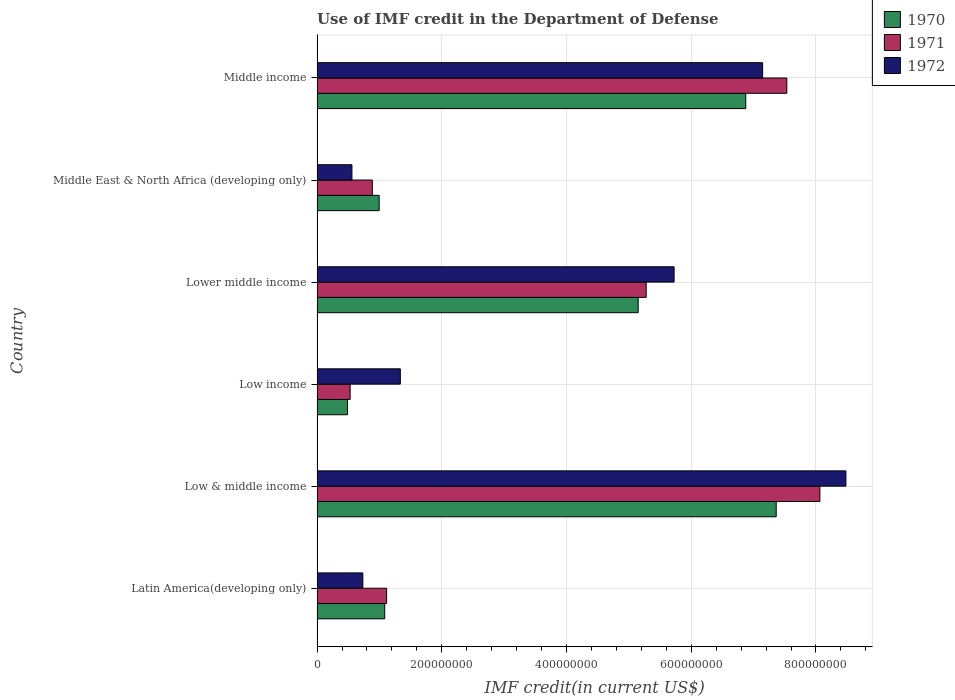How many different coloured bars are there?
Offer a terse response. 3. Are the number of bars on each tick of the Y-axis equal?
Your answer should be very brief. Yes. How many bars are there on the 4th tick from the top?
Provide a short and direct response. 3. What is the label of the 6th group of bars from the top?
Keep it short and to the point. Latin America(developing only). In how many cases, is the number of bars for a given country not equal to the number of legend labels?
Your answer should be compact. 0. What is the IMF credit in the Department of Defense in 1971 in Middle income?
Your response must be concise. 7.53e+08. Across all countries, what is the maximum IMF credit in the Department of Defense in 1971?
Provide a succinct answer. 8.06e+08. Across all countries, what is the minimum IMF credit in the Department of Defense in 1972?
Offer a terse response. 5.59e+07. In which country was the IMF credit in the Department of Defense in 1972 maximum?
Give a very brief answer. Low & middle income. In which country was the IMF credit in the Department of Defense in 1972 minimum?
Make the answer very short. Middle East & North Africa (developing only). What is the total IMF credit in the Department of Defense in 1972 in the graph?
Ensure brevity in your answer.  2.40e+09. What is the difference between the IMF credit in the Department of Defense in 1970 in Middle East & North Africa (developing only) and that in Middle income?
Offer a terse response. -5.88e+08. What is the difference between the IMF credit in the Department of Defense in 1971 in Middle income and the IMF credit in the Department of Defense in 1972 in Low & middle income?
Keep it short and to the point. -9.48e+07. What is the average IMF credit in the Department of Defense in 1971 per country?
Offer a terse response. 3.90e+08. What is the difference between the IMF credit in the Department of Defense in 1970 and IMF credit in the Department of Defense in 1972 in Low & middle income?
Provide a short and direct response. -1.12e+08. In how many countries, is the IMF credit in the Department of Defense in 1971 greater than 800000000 US$?
Keep it short and to the point. 1. What is the ratio of the IMF credit in the Department of Defense in 1971 in Lower middle income to that in Middle income?
Keep it short and to the point. 0.7. What is the difference between the highest and the second highest IMF credit in the Department of Defense in 1971?
Make the answer very short. 5.30e+07. What is the difference between the highest and the lowest IMF credit in the Department of Defense in 1970?
Give a very brief answer. 6.87e+08. In how many countries, is the IMF credit in the Department of Defense in 1970 greater than the average IMF credit in the Department of Defense in 1970 taken over all countries?
Your response must be concise. 3. What does the 3rd bar from the bottom in Middle East & North Africa (developing only) represents?
Keep it short and to the point. 1972. Are all the bars in the graph horizontal?
Provide a short and direct response. Yes. How many countries are there in the graph?
Offer a terse response. 6. What is the difference between two consecutive major ticks on the X-axis?
Your answer should be compact. 2.00e+08. Are the values on the major ticks of X-axis written in scientific E-notation?
Your response must be concise. No. Does the graph contain any zero values?
Offer a terse response. No. How many legend labels are there?
Your answer should be compact. 3. How are the legend labels stacked?
Keep it short and to the point. Vertical. What is the title of the graph?
Your answer should be very brief. Use of IMF credit in the Department of Defense. What is the label or title of the X-axis?
Your answer should be very brief. IMF credit(in current US$). What is the label or title of the Y-axis?
Offer a very short reply. Country. What is the IMF credit(in current US$) of 1970 in Latin America(developing only)?
Provide a short and direct response. 1.09e+08. What is the IMF credit(in current US$) of 1971 in Latin America(developing only)?
Your answer should be compact. 1.12e+08. What is the IMF credit(in current US$) of 1972 in Latin America(developing only)?
Ensure brevity in your answer.  7.34e+07. What is the IMF credit(in current US$) in 1970 in Low & middle income?
Your answer should be very brief. 7.36e+08. What is the IMF credit(in current US$) of 1971 in Low & middle income?
Keep it short and to the point. 8.06e+08. What is the IMF credit(in current US$) in 1972 in Low & middle income?
Your answer should be compact. 8.48e+08. What is the IMF credit(in current US$) in 1970 in Low income?
Offer a terse response. 4.88e+07. What is the IMF credit(in current US$) of 1971 in Low income?
Ensure brevity in your answer.  5.30e+07. What is the IMF credit(in current US$) of 1972 in Low income?
Keep it short and to the point. 1.34e+08. What is the IMF credit(in current US$) of 1970 in Lower middle income?
Offer a very short reply. 5.15e+08. What is the IMF credit(in current US$) of 1971 in Lower middle income?
Keep it short and to the point. 5.28e+08. What is the IMF credit(in current US$) in 1972 in Lower middle income?
Offer a very short reply. 5.73e+08. What is the IMF credit(in current US$) in 1970 in Middle East & North Africa (developing only)?
Ensure brevity in your answer.  9.96e+07. What is the IMF credit(in current US$) of 1971 in Middle East & North Africa (developing only)?
Keep it short and to the point. 8.86e+07. What is the IMF credit(in current US$) of 1972 in Middle East & North Africa (developing only)?
Offer a terse response. 5.59e+07. What is the IMF credit(in current US$) of 1970 in Middle income?
Provide a short and direct response. 6.87e+08. What is the IMF credit(in current US$) of 1971 in Middle income?
Keep it short and to the point. 7.53e+08. What is the IMF credit(in current US$) in 1972 in Middle income?
Keep it short and to the point. 7.14e+08. Across all countries, what is the maximum IMF credit(in current US$) in 1970?
Ensure brevity in your answer.  7.36e+08. Across all countries, what is the maximum IMF credit(in current US$) of 1971?
Ensure brevity in your answer.  8.06e+08. Across all countries, what is the maximum IMF credit(in current US$) in 1972?
Your response must be concise. 8.48e+08. Across all countries, what is the minimum IMF credit(in current US$) in 1970?
Provide a succinct answer. 4.88e+07. Across all countries, what is the minimum IMF credit(in current US$) of 1971?
Provide a short and direct response. 5.30e+07. Across all countries, what is the minimum IMF credit(in current US$) in 1972?
Ensure brevity in your answer.  5.59e+07. What is the total IMF credit(in current US$) in 1970 in the graph?
Keep it short and to the point. 2.20e+09. What is the total IMF credit(in current US$) in 1971 in the graph?
Offer a terse response. 2.34e+09. What is the total IMF credit(in current US$) of 1972 in the graph?
Your answer should be very brief. 2.40e+09. What is the difference between the IMF credit(in current US$) of 1970 in Latin America(developing only) and that in Low & middle income?
Offer a very short reply. -6.28e+08. What is the difference between the IMF credit(in current US$) in 1971 in Latin America(developing only) and that in Low & middle income?
Your answer should be very brief. -6.95e+08. What is the difference between the IMF credit(in current US$) of 1972 in Latin America(developing only) and that in Low & middle income?
Make the answer very short. -7.75e+08. What is the difference between the IMF credit(in current US$) of 1970 in Latin America(developing only) and that in Low income?
Offer a terse response. 5.97e+07. What is the difference between the IMF credit(in current US$) in 1971 in Latin America(developing only) and that in Low income?
Give a very brief answer. 5.85e+07. What is the difference between the IMF credit(in current US$) in 1972 in Latin America(developing only) and that in Low income?
Your answer should be very brief. -6.01e+07. What is the difference between the IMF credit(in current US$) in 1970 in Latin America(developing only) and that in Lower middle income?
Your response must be concise. -4.06e+08. What is the difference between the IMF credit(in current US$) of 1971 in Latin America(developing only) and that in Lower middle income?
Make the answer very short. -4.16e+08. What is the difference between the IMF credit(in current US$) in 1972 in Latin America(developing only) and that in Lower middle income?
Your response must be concise. -4.99e+08. What is the difference between the IMF credit(in current US$) of 1970 in Latin America(developing only) and that in Middle East & North Africa (developing only)?
Ensure brevity in your answer.  8.90e+06. What is the difference between the IMF credit(in current US$) in 1971 in Latin America(developing only) and that in Middle East & North Africa (developing only)?
Your response must be concise. 2.29e+07. What is the difference between the IMF credit(in current US$) of 1972 in Latin America(developing only) and that in Middle East & North Africa (developing only)?
Keep it short and to the point. 1.75e+07. What is the difference between the IMF credit(in current US$) of 1970 in Latin America(developing only) and that in Middle income?
Ensure brevity in your answer.  -5.79e+08. What is the difference between the IMF credit(in current US$) of 1971 in Latin America(developing only) and that in Middle income?
Give a very brief answer. -6.42e+08. What is the difference between the IMF credit(in current US$) in 1972 in Latin America(developing only) and that in Middle income?
Your answer should be very brief. -6.41e+08. What is the difference between the IMF credit(in current US$) of 1970 in Low & middle income and that in Low income?
Keep it short and to the point. 6.87e+08. What is the difference between the IMF credit(in current US$) in 1971 in Low & middle income and that in Low income?
Offer a terse response. 7.53e+08. What is the difference between the IMF credit(in current US$) in 1972 in Low & middle income and that in Low income?
Give a very brief answer. 7.14e+08. What is the difference between the IMF credit(in current US$) of 1970 in Low & middle income and that in Lower middle income?
Your response must be concise. 2.21e+08. What is the difference between the IMF credit(in current US$) in 1971 in Low & middle income and that in Lower middle income?
Keep it short and to the point. 2.79e+08. What is the difference between the IMF credit(in current US$) of 1972 in Low & middle income and that in Lower middle income?
Offer a terse response. 2.76e+08. What is the difference between the IMF credit(in current US$) of 1970 in Low & middle income and that in Middle East & North Africa (developing only)?
Your response must be concise. 6.37e+08. What is the difference between the IMF credit(in current US$) of 1971 in Low & middle income and that in Middle East & North Africa (developing only)?
Give a very brief answer. 7.18e+08. What is the difference between the IMF credit(in current US$) in 1972 in Low & middle income and that in Middle East & North Africa (developing only)?
Keep it short and to the point. 7.92e+08. What is the difference between the IMF credit(in current US$) of 1970 in Low & middle income and that in Middle income?
Offer a very short reply. 4.88e+07. What is the difference between the IMF credit(in current US$) in 1971 in Low & middle income and that in Middle income?
Make the answer very short. 5.30e+07. What is the difference between the IMF credit(in current US$) in 1972 in Low & middle income and that in Middle income?
Your answer should be very brief. 1.34e+08. What is the difference between the IMF credit(in current US$) in 1970 in Low income and that in Lower middle income?
Give a very brief answer. -4.66e+08. What is the difference between the IMF credit(in current US$) of 1971 in Low income and that in Lower middle income?
Offer a very short reply. -4.75e+08. What is the difference between the IMF credit(in current US$) of 1972 in Low income and that in Lower middle income?
Offer a very short reply. -4.39e+08. What is the difference between the IMF credit(in current US$) in 1970 in Low income and that in Middle East & North Africa (developing only)?
Your answer should be very brief. -5.08e+07. What is the difference between the IMF credit(in current US$) of 1971 in Low income and that in Middle East & North Africa (developing only)?
Offer a very short reply. -3.56e+07. What is the difference between the IMF credit(in current US$) of 1972 in Low income and that in Middle East & North Africa (developing only)?
Keep it short and to the point. 7.76e+07. What is the difference between the IMF credit(in current US$) of 1970 in Low income and that in Middle income?
Ensure brevity in your answer.  -6.39e+08. What is the difference between the IMF credit(in current US$) in 1971 in Low income and that in Middle income?
Provide a succinct answer. -7.00e+08. What is the difference between the IMF credit(in current US$) of 1972 in Low income and that in Middle income?
Your answer should be very brief. -5.81e+08. What is the difference between the IMF credit(in current US$) in 1970 in Lower middle income and that in Middle East & North Africa (developing only)?
Offer a very short reply. 4.15e+08. What is the difference between the IMF credit(in current US$) in 1971 in Lower middle income and that in Middle East & North Africa (developing only)?
Offer a very short reply. 4.39e+08. What is the difference between the IMF credit(in current US$) of 1972 in Lower middle income and that in Middle East & North Africa (developing only)?
Your answer should be compact. 5.17e+08. What is the difference between the IMF credit(in current US$) of 1970 in Lower middle income and that in Middle income?
Provide a succinct answer. -1.72e+08. What is the difference between the IMF credit(in current US$) of 1971 in Lower middle income and that in Middle income?
Your answer should be very brief. -2.25e+08. What is the difference between the IMF credit(in current US$) of 1972 in Lower middle income and that in Middle income?
Make the answer very short. -1.42e+08. What is the difference between the IMF credit(in current US$) in 1970 in Middle East & North Africa (developing only) and that in Middle income?
Make the answer very short. -5.88e+08. What is the difference between the IMF credit(in current US$) in 1971 in Middle East & North Africa (developing only) and that in Middle income?
Keep it short and to the point. -6.65e+08. What is the difference between the IMF credit(in current US$) of 1972 in Middle East & North Africa (developing only) and that in Middle income?
Keep it short and to the point. -6.59e+08. What is the difference between the IMF credit(in current US$) in 1970 in Latin America(developing only) and the IMF credit(in current US$) in 1971 in Low & middle income?
Your answer should be very brief. -6.98e+08. What is the difference between the IMF credit(in current US$) in 1970 in Latin America(developing only) and the IMF credit(in current US$) in 1972 in Low & middle income?
Provide a succinct answer. -7.40e+08. What is the difference between the IMF credit(in current US$) in 1971 in Latin America(developing only) and the IMF credit(in current US$) in 1972 in Low & middle income?
Provide a short and direct response. -7.37e+08. What is the difference between the IMF credit(in current US$) of 1970 in Latin America(developing only) and the IMF credit(in current US$) of 1971 in Low income?
Offer a terse response. 5.55e+07. What is the difference between the IMF credit(in current US$) in 1970 in Latin America(developing only) and the IMF credit(in current US$) in 1972 in Low income?
Make the answer very short. -2.50e+07. What is the difference between the IMF credit(in current US$) of 1971 in Latin America(developing only) and the IMF credit(in current US$) of 1972 in Low income?
Your response must be concise. -2.20e+07. What is the difference between the IMF credit(in current US$) in 1970 in Latin America(developing only) and the IMF credit(in current US$) in 1971 in Lower middle income?
Give a very brief answer. -4.19e+08. What is the difference between the IMF credit(in current US$) in 1970 in Latin America(developing only) and the IMF credit(in current US$) in 1972 in Lower middle income?
Provide a succinct answer. -4.64e+08. What is the difference between the IMF credit(in current US$) of 1971 in Latin America(developing only) and the IMF credit(in current US$) of 1972 in Lower middle income?
Your answer should be very brief. -4.61e+08. What is the difference between the IMF credit(in current US$) in 1970 in Latin America(developing only) and the IMF credit(in current US$) in 1971 in Middle East & North Africa (developing only)?
Keep it short and to the point. 1.99e+07. What is the difference between the IMF credit(in current US$) in 1970 in Latin America(developing only) and the IMF credit(in current US$) in 1972 in Middle East & North Africa (developing only)?
Keep it short and to the point. 5.26e+07. What is the difference between the IMF credit(in current US$) in 1971 in Latin America(developing only) and the IMF credit(in current US$) in 1972 in Middle East & North Africa (developing only)?
Provide a succinct answer. 5.56e+07. What is the difference between the IMF credit(in current US$) of 1970 in Latin America(developing only) and the IMF credit(in current US$) of 1971 in Middle income?
Keep it short and to the point. -6.45e+08. What is the difference between the IMF credit(in current US$) in 1970 in Latin America(developing only) and the IMF credit(in current US$) in 1972 in Middle income?
Offer a terse response. -6.06e+08. What is the difference between the IMF credit(in current US$) of 1971 in Latin America(developing only) and the IMF credit(in current US$) of 1972 in Middle income?
Give a very brief answer. -6.03e+08. What is the difference between the IMF credit(in current US$) in 1970 in Low & middle income and the IMF credit(in current US$) in 1971 in Low income?
Provide a short and direct response. 6.83e+08. What is the difference between the IMF credit(in current US$) in 1970 in Low & middle income and the IMF credit(in current US$) in 1972 in Low income?
Offer a very short reply. 6.03e+08. What is the difference between the IMF credit(in current US$) in 1971 in Low & middle income and the IMF credit(in current US$) in 1972 in Low income?
Offer a very short reply. 6.73e+08. What is the difference between the IMF credit(in current US$) of 1970 in Low & middle income and the IMF credit(in current US$) of 1971 in Lower middle income?
Make the answer very short. 2.08e+08. What is the difference between the IMF credit(in current US$) in 1970 in Low & middle income and the IMF credit(in current US$) in 1972 in Lower middle income?
Offer a very short reply. 1.64e+08. What is the difference between the IMF credit(in current US$) of 1971 in Low & middle income and the IMF credit(in current US$) of 1972 in Lower middle income?
Keep it short and to the point. 2.34e+08. What is the difference between the IMF credit(in current US$) in 1970 in Low & middle income and the IMF credit(in current US$) in 1971 in Middle East & North Africa (developing only)?
Give a very brief answer. 6.48e+08. What is the difference between the IMF credit(in current US$) of 1970 in Low & middle income and the IMF credit(in current US$) of 1972 in Middle East & North Africa (developing only)?
Keep it short and to the point. 6.80e+08. What is the difference between the IMF credit(in current US$) of 1971 in Low & middle income and the IMF credit(in current US$) of 1972 in Middle East & North Africa (developing only)?
Make the answer very short. 7.50e+08. What is the difference between the IMF credit(in current US$) of 1970 in Low & middle income and the IMF credit(in current US$) of 1971 in Middle income?
Offer a very short reply. -1.70e+07. What is the difference between the IMF credit(in current US$) in 1970 in Low & middle income and the IMF credit(in current US$) in 1972 in Middle income?
Ensure brevity in your answer.  2.18e+07. What is the difference between the IMF credit(in current US$) in 1971 in Low & middle income and the IMF credit(in current US$) in 1972 in Middle income?
Provide a succinct answer. 9.18e+07. What is the difference between the IMF credit(in current US$) in 1970 in Low income and the IMF credit(in current US$) in 1971 in Lower middle income?
Offer a terse response. -4.79e+08. What is the difference between the IMF credit(in current US$) in 1970 in Low income and the IMF credit(in current US$) in 1972 in Lower middle income?
Keep it short and to the point. -5.24e+08. What is the difference between the IMF credit(in current US$) in 1971 in Low income and the IMF credit(in current US$) in 1972 in Lower middle income?
Give a very brief answer. -5.20e+08. What is the difference between the IMF credit(in current US$) of 1970 in Low income and the IMF credit(in current US$) of 1971 in Middle East & North Africa (developing only)?
Your response must be concise. -3.98e+07. What is the difference between the IMF credit(in current US$) in 1970 in Low income and the IMF credit(in current US$) in 1972 in Middle East & North Africa (developing only)?
Your response must be concise. -7.12e+06. What is the difference between the IMF credit(in current US$) in 1971 in Low income and the IMF credit(in current US$) in 1972 in Middle East & North Africa (developing only)?
Provide a short and direct response. -2.90e+06. What is the difference between the IMF credit(in current US$) in 1970 in Low income and the IMF credit(in current US$) in 1971 in Middle income?
Your answer should be very brief. -7.04e+08. What is the difference between the IMF credit(in current US$) in 1970 in Low income and the IMF credit(in current US$) in 1972 in Middle income?
Ensure brevity in your answer.  -6.66e+08. What is the difference between the IMF credit(in current US$) of 1971 in Low income and the IMF credit(in current US$) of 1972 in Middle income?
Your answer should be compact. -6.61e+08. What is the difference between the IMF credit(in current US$) of 1970 in Lower middle income and the IMF credit(in current US$) of 1971 in Middle East & North Africa (developing only)?
Provide a succinct answer. 4.26e+08. What is the difference between the IMF credit(in current US$) in 1970 in Lower middle income and the IMF credit(in current US$) in 1972 in Middle East & North Africa (developing only)?
Provide a succinct answer. 4.59e+08. What is the difference between the IMF credit(in current US$) of 1971 in Lower middle income and the IMF credit(in current US$) of 1972 in Middle East & North Africa (developing only)?
Offer a terse response. 4.72e+08. What is the difference between the IMF credit(in current US$) in 1970 in Lower middle income and the IMF credit(in current US$) in 1971 in Middle income?
Give a very brief answer. -2.38e+08. What is the difference between the IMF credit(in current US$) in 1970 in Lower middle income and the IMF credit(in current US$) in 1972 in Middle income?
Your response must be concise. -2.00e+08. What is the difference between the IMF credit(in current US$) in 1971 in Lower middle income and the IMF credit(in current US$) in 1972 in Middle income?
Offer a very short reply. -1.87e+08. What is the difference between the IMF credit(in current US$) of 1970 in Middle East & North Africa (developing only) and the IMF credit(in current US$) of 1971 in Middle income?
Make the answer very short. -6.54e+08. What is the difference between the IMF credit(in current US$) in 1970 in Middle East & North Africa (developing only) and the IMF credit(in current US$) in 1972 in Middle income?
Ensure brevity in your answer.  -6.15e+08. What is the difference between the IMF credit(in current US$) in 1971 in Middle East & North Africa (developing only) and the IMF credit(in current US$) in 1972 in Middle income?
Ensure brevity in your answer.  -6.26e+08. What is the average IMF credit(in current US$) in 1970 per country?
Ensure brevity in your answer.  3.66e+08. What is the average IMF credit(in current US$) of 1971 per country?
Keep it short and to the point. 3.90e+08. What is the average IMF credit(in current US$) of 1972 per country?
Your answer should be very brief. 4.00e+08. What is the difference between the IMF credit(in current US$) in 1970 and IMF credit(in current US$) in 1971 in Latin America(developing only)?
Keep it short and to the point. -3.01e+06. What is the difference between the IMF credit(in current US$) of 1970 and IMF credit(in current US$) of 1972 in Latin America(developing only)?
Ensure brevity in your answer.  3.51e+07. What is the difference between the IMF credit(in current US$) of 1971 and IMF credit(in current US$) of 1972 in Latin America(developing only)?
Your answer should be very brief. 3.81e+07. What is the difference between the IMF credit(in current US$) of 1970 and IMF credit(in current US$) of 1971 in Low & middle income?
Your response must be concise. -7.00e+07. What is the difference between the IMF credit(in current US$) in 1970 and IMF credit(in current US$) in 1972 in Low & middle income?
Make the answer very short. -1.12e+08. What is the difference between the IMF credit(in current US$) in 1971 and IMF credit(in current US$) in 1972 in Low & middle income?
Make the answer very short. -4.18e+07. What is the difference between the IMF credit(in current US$) in 1970 and IMF credit(in current US$) in 1971 in Low income?
Offer a very short reply. -4.21e+06. What is the difference between the IMF credit(in current US$) in 1970 and IMF credit(in current US$) in 1972 in Low income?
Provide a succinct answer. -8.47e+07. What is the difference between the IMF credit(in current US$) in 1971 and IMF credit(in current US$) in 1972 in Low income?
Your answer should be very brief. -8.05e+07. What is the difference between the IMF credit(in current US$) in 1970 and IMF credit(in current US$) in 1971 in Lower middle income?
Make the answer very short. -1.28e+07. What is the difference between the IMF credit(in current US$) in 1970 and IMF credit(in current US$) in 1972 in Lower middle income?
Give a very brief answer. -5.76e+07. What is the difference between the IMF credit(in current US$) of 1971 and IMF credit(in current US$) of 1972 in Lower middle income?
Offer a very short reply. -4.48e+07. What is the difference between the IMF credit(in current US$) in 1970 and IMF credit(in current US$) in 1971 in Middle East & North Africa (developing only)?
Offer a terse response. 1.10e+07. What is the difference between the IMF credit(in current US$) in 1970 and IMF credit(in current US$) in 1972 in Middle East & North Africa (developing only)?
Provide a short and direct response. 4.37e+07. What is the difference between the IMF credit(in current US$) of 1971 and IMF credit(in current US$) of 1972 in Middle East & North Africa (developing only)?
Your response must be concise. 3.27e+07. What is the difference between the IMF credit(in current US$) of 1970 and IMF credit(in current US$) of 1971 in Middle income?
Your response must be concise. -6.58e+07. What is the difference between the IMF credit(in current US$) in 1970 and IMF credit(in current US$) in 1972 in Middle income?
Your answer should be very brief. -2.71e+07. What is the difference between the IMF credit(in current US$) in 1971 and IMF credit(in current US$) in 1972 in Middle income?
Ensure brevity in your answer.  3.88e+07. What is the ratio of the IMF credit(in current US$) of 1970 in Latin America(developing only) to that in Low & middle income?
Keep it short and to the point. 0.15. What is the ratio of the IMF credit(in current US$) of 1971 in Latin America(developing only) to that in Low & middle income?
Keep it short and to the point. 0.14. What is the ratio of the IMF credit(in current US$) of 1972 in Latin America(developing only) to that in Low & middle income?
Ensure brevity in your answer.  0.09. What is the ratio of the IMF credit(in current US$) in 1970 in Latin America(developing only) to that in Low income?
Your answer should be compact. 2.22. What is the ratio of the IMF credit(in current US$) of 1971 in Latin America(developing only) to that in Low income?
Your answer should be very brief. 2.1. What is the ratio of the IMF credit(in current US$) in 1972 in Latin America(developing only) to that in Low income?
Provide a succinct answer. 0.55. What is the ratio of the IMF credit(in current US$) in 1970 in Latin America(developing only) to that in Lower middle income?
Offer a very short reply. 0.21. What is the ratio of the IMF credit(in current US$) of 1971 in Latin America(developing only) to that in Lower middle income?
Your answer should be compact. 0.21. What is the ratio of the IMF credit(in current US$) of 1972 in Latin America(developing only) to that in Lower middle income?
Provide a short and direct response. 0.13. What is the ratio of the IMF credit(in current US$) in 1970 in Latin America(developing only) to that in Middle East & North Africa (developing only)?
Keep it short and to the point. 1.09. What is the ratio of the IMF credit(in current US$) in 1971 in Latin America(developing only) to that in Middle East & North Africa (developing only)?
Give a very brief answer. 1.26. What is the ratio of the IMF credit(in current US$) in 1972 in Latin America(developing only) to that in Middle East & North Africa (developing only)?
Your answer should be very brief. 1.31. What is the ratio of the IMF credit(in current US$) in 1970 in Latin America(developing only) to that in Middle income?
Your response must be concise. 0.16. What is the ratio of the IMF credit(in current US$) in 1971 in Latin America(developing only) to that in Middle income?
Keep it short and to the point. 0.15. What is the ratio of the IMF credit(in current US$) of 1972 in Latin America(developing only) to that in Middle income?
Give a very brief answer. 0.1. What is the ratio of the IMF credit(in current US$) in 1970 in Low & middle income to that in Low income?
Give a very brief answer. 15.08. What is the ratio of the IMF credit(in current US$) of 1971 in Low & middle income to that in Low income?
Give a very brief answer. 15.21. What is the ratio of the IMF credit(in current US$) in 1972 in Low & middle income to that in Low income?
Offer a terse response. 6.35. What is the ratio of the IMF credit(in current US$) in 1970 in Low & middle income to that in Lower middle income?
Your response must be concise. 1.43. What is the ratio of the IMF credit(in current US$) of 1971 in Low & middle income to that in Lower middle income?
Your response must be concise. 1.53. What is the ratio of the IMF credit(in current US$) in 1972 in Low & middle income to that in Lower middle income?
Ensure brevity in your answer.  1.48. What is the ratio of the IMF credit(in current US$) of 1970 in Low & middle income to that in Middle East & North Africa (developing only)?
Offer a terse response. 7.39. What is the ratio of the IMF credit(in current US$) of 1971 in Low & middle income to that in Middle East & North Africa (developing only)?
Give a very brief answer. 9.1. What is the ratio of the IMF credit(in current US$) of 1972 in Low & middle income to that in Middle East & North Africa (developing only)?
Keep it short and to the point. 15.16. What is the ratio of the IMF credit(in current US$) in 1970 in Low & middle income to that in Middle income?
Offer a very short reply. 1.07. What is the ratio of the IMF credit(in current US$) in 1971 in Low & middle income to that in Middle income?
Your response must be concise. 1.07. What is the ratio of the IMF credit(in current US$) in 1972 in Low & middle income to that in Middle income?
Keep it short and to the point. 1.19. What is the ratio of the IMF credit(in current US$) of 1970 in Low income to that in Lower middle income?
Provide a succinct answer. 0.09. What is the ratio of the IMF credit(in current US$) in 1971 in Low income to that in Lower middle income?
Your response must be concise. 0.1. What is the ratio of the IMF credit(in current US$) of 1972 in Low income to that in Lower middle income?
Your response must be concise. 0.23. What is the ratio of the IMF credit(in current US$) of 1970 in Low income to that in Middle East & North Africa (developing only)?
Make the answer very short. 0.49. What is the ratio of the IMF credit(in current US$) in 1971 in Low income to that in Middle East & North Africa (developing only)?
Your answer should be very brief. 0.6. What is the ratio of the IMF credit(in current US$) of 1972 in Low income to that in Middle East & North Africa (developing only)?
Give a very brief answer. 2.39. What is the ratio of the IMF credit(in current US$) of 1970 in Low income to that in Middle income?
Offer a terse response. 0.07. What is the ratio of the IMF credit(in current US$) of 1971 in Low income to that in Middle income?
Make the answer very short. 0.07. What is the ratio of the IMF credit(in current US$) of 1972 in Low income to that in Middle income?
Provide a short and direct response. 0.19. What is the ratio of the IMF credit(in current US$) in 1970 in Lower middle income to that in Middle East & North Africa (developing only)?
Provide a succinct answer. 5.17. What is the ratio of the IMF credit(in current US$) of 1971 in Lower middle income to that in Middle East & North Africa (developing only)?
Give a very brief answer. 5.95. What is the ratio of the IMF credit(in current US$) of 1972 in Lower middle income to that in Middle East & North Africa (developing only)?
Give a very brief answer. 10.24. What is the ratio of the IMF credit(in current US$) in 1970 in Lower middle income to that in Middle income?
Your answer should be very brief. 0.75. What is the ratio of the IMF credit(in current US$) of 1971 in Lower middle income to that in Middle income?
Your response must be concise. 0.7. What is the ratio of the IMF credit(in current US$) in 1972 in Lower middle income to that in Middle income?
Your answer should be compact. 0.8. What is the ratio of the IMF credit(in current US$) in 1970 in Middle East & North Africa (developing only) to that in Middle income?
Provide a succinct answer. 0.14. What is the ratio of the IMF credit(in current US$) in 1971 in Middle East & North Africa (developing only) to that in Middle income?
Provide a succinct answer. 0.12. What is the ratio of the IMF credit(in current US$) in 1972 in Middle East & North Africa (developing only) to that in Middle income?
Make the answer very short. 0.08. What is the difference between the highest and the second highest IMF credit(in current US$) in 1970?
Ensure brevity in your answer.  4.88e+07. What is the difference between the highest and the second highest IMF credit(in current US$) of 1971?
Provide a succinct answer. 5.30e+07. What is the difference between the highest and the second highest IMF credit(in current US$) in 1972?
Ensure brevity in your answer.  1.34e+08. What is the difference between the highest and the lowest IMF credit(in current US$) in 1970?
Give a very brief answer. 6.87e+08. What is the difference between the highest and the lowest IMF credit(in current US$) in 1971?
Your response must be concise. 7.53e+08. What is the difference between the highest and the lowest IMF credit(in current US$) of 1972?
Your answer should be very brief. 7.92e+08. 